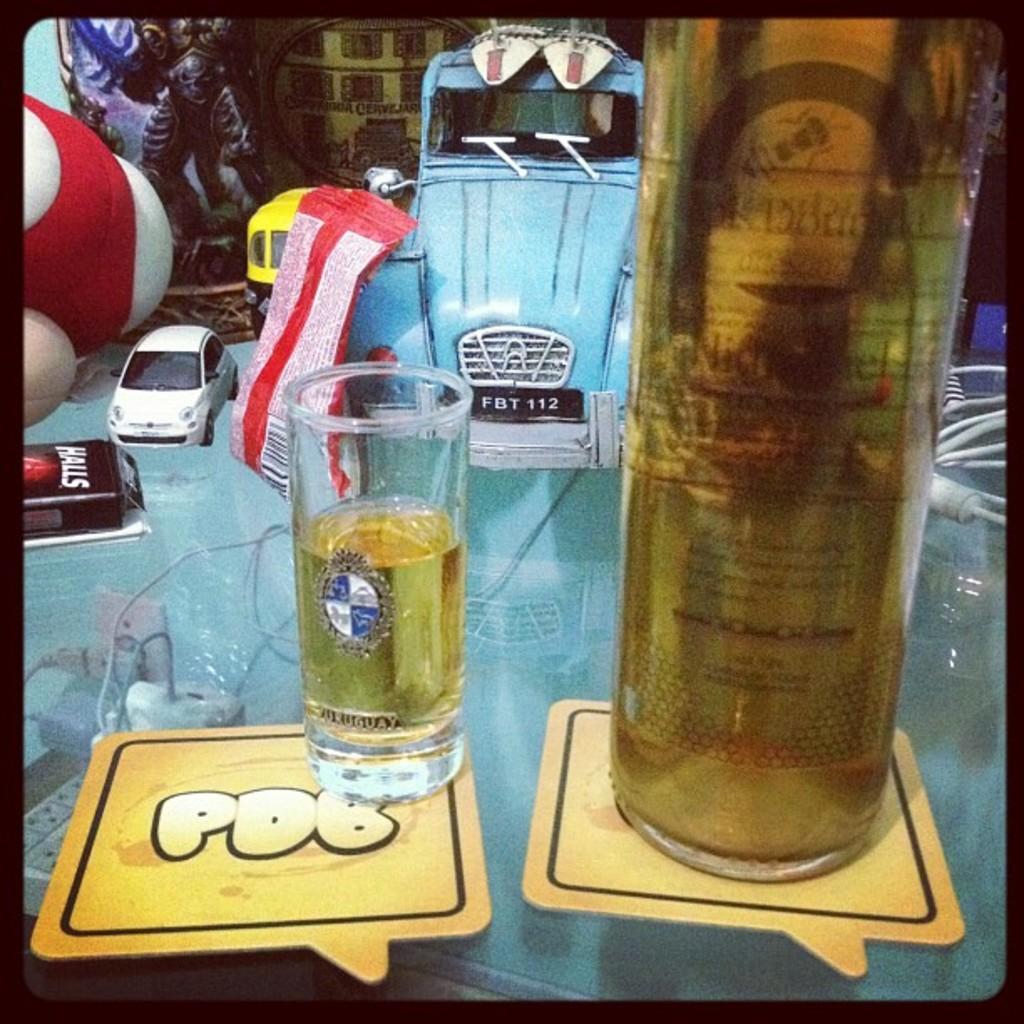What does the coaster say?
Your answer should be compact. Pdb. What brand is the product in the black package?
Offer a very short reply. Halls. 